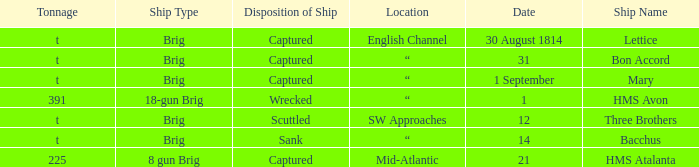With a tonnage of 225 what is the ship type? 8 gun Brig. 